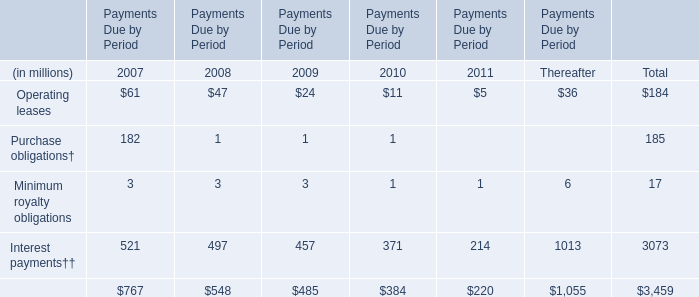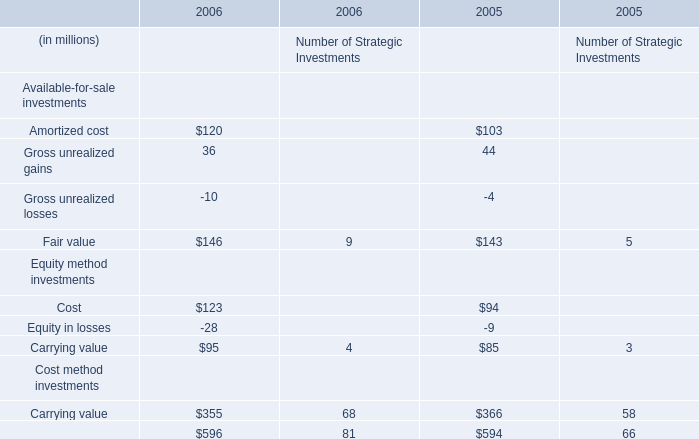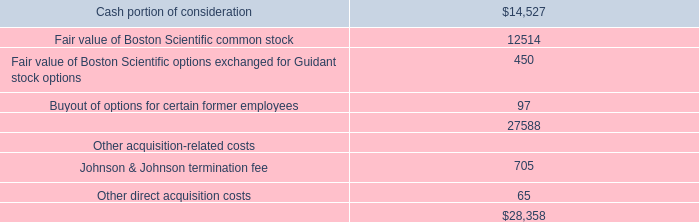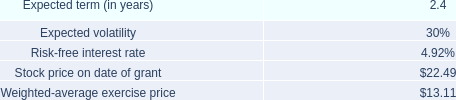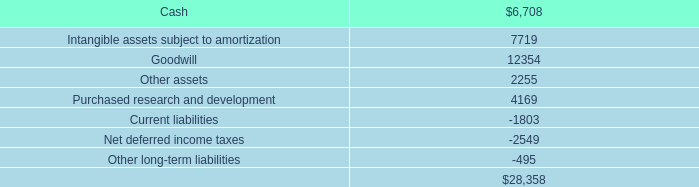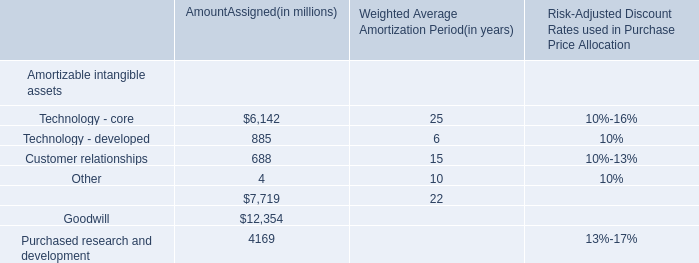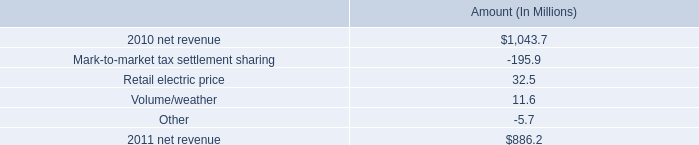What's the total amount of Amortized cost and Gross unrealized gains in 2006? (in million) 
Computations: (120 + 36)
Answer: 156.0. 